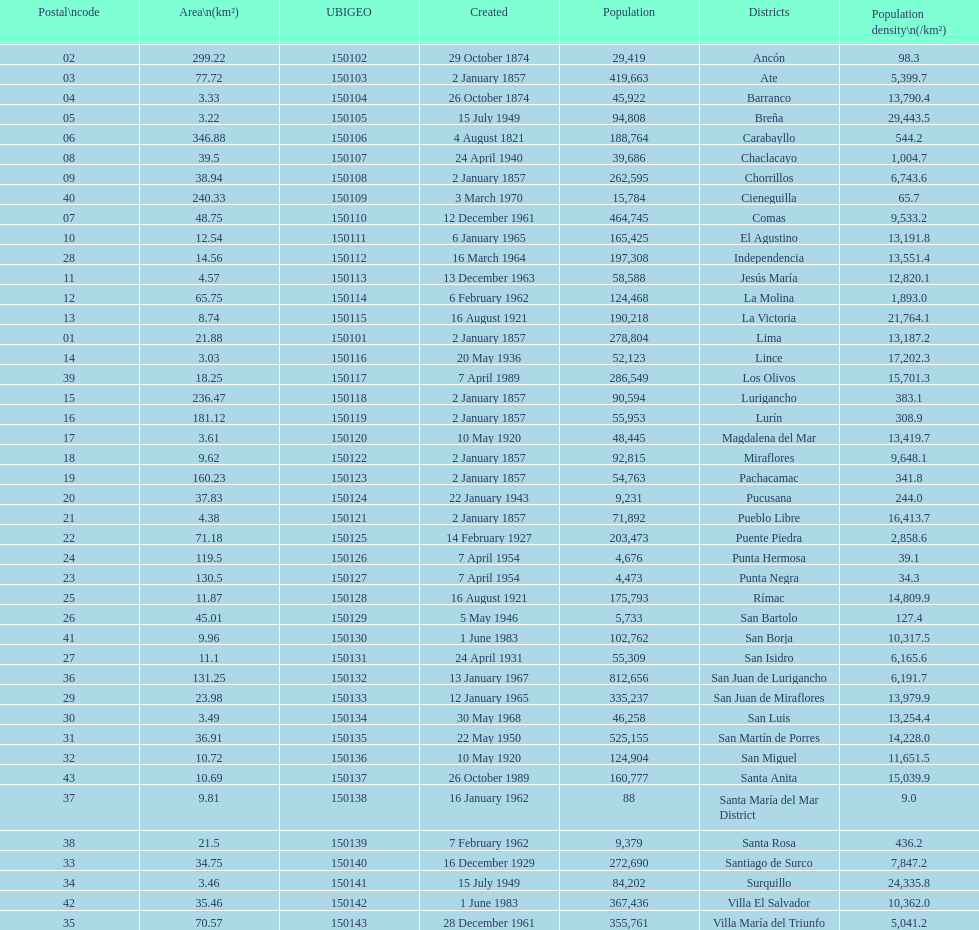Which is the largest district in terms of population? San Juan de Lurigancho. 